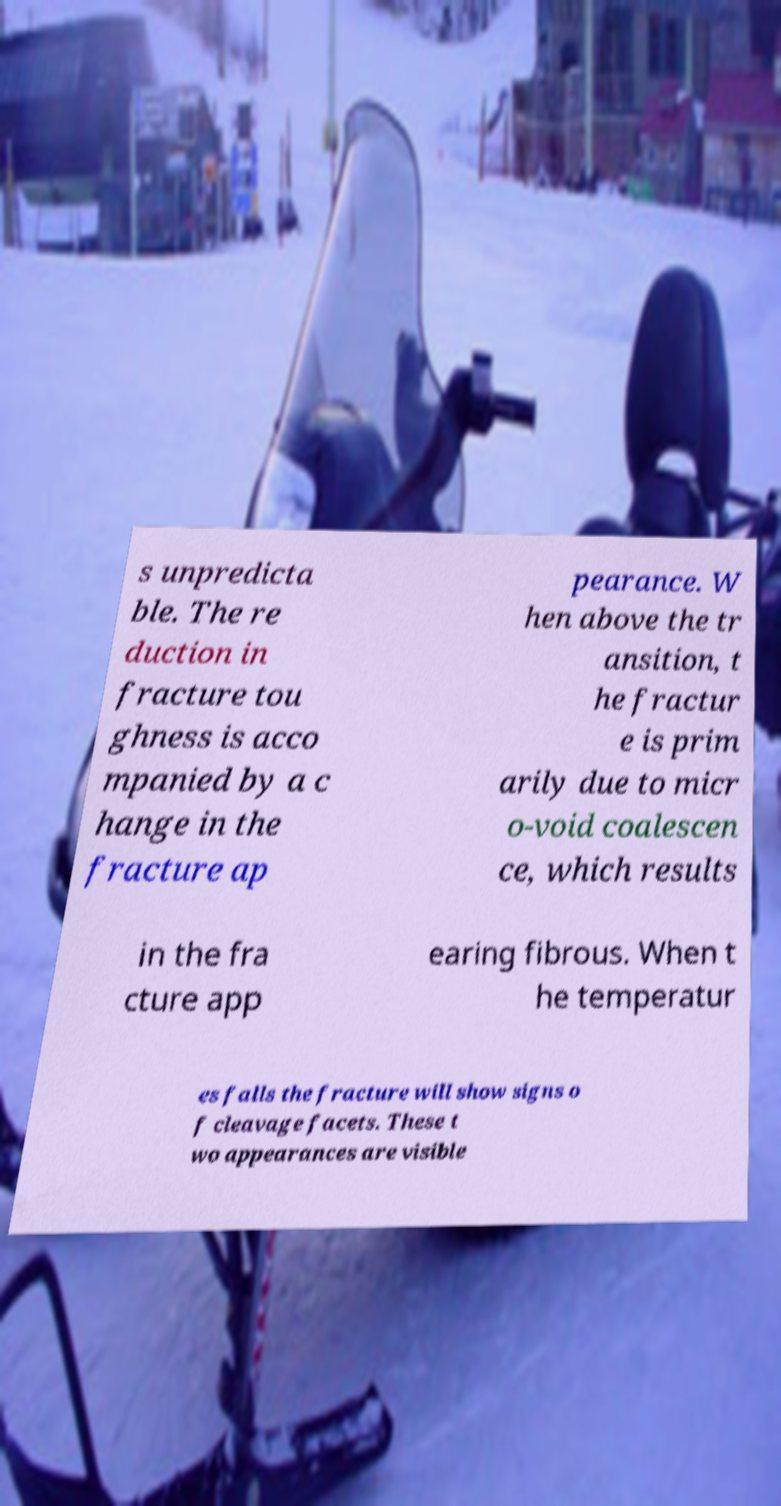There's text embedded in this image that I need extracted. Can you transcribe it verbatim? s unpredicta ble. The re duction in fracture tou ghness is acco mpanied by a c hange in the fracture ap pearance. W hen above the tr ansition, t he fractur e is prim arily due to micr o-void coalescen ce, which results in the fra cture app earing fibrous. When t he temperatur es falls the fracture will show signs o f cleavage facets. These t wo appearances are visible 